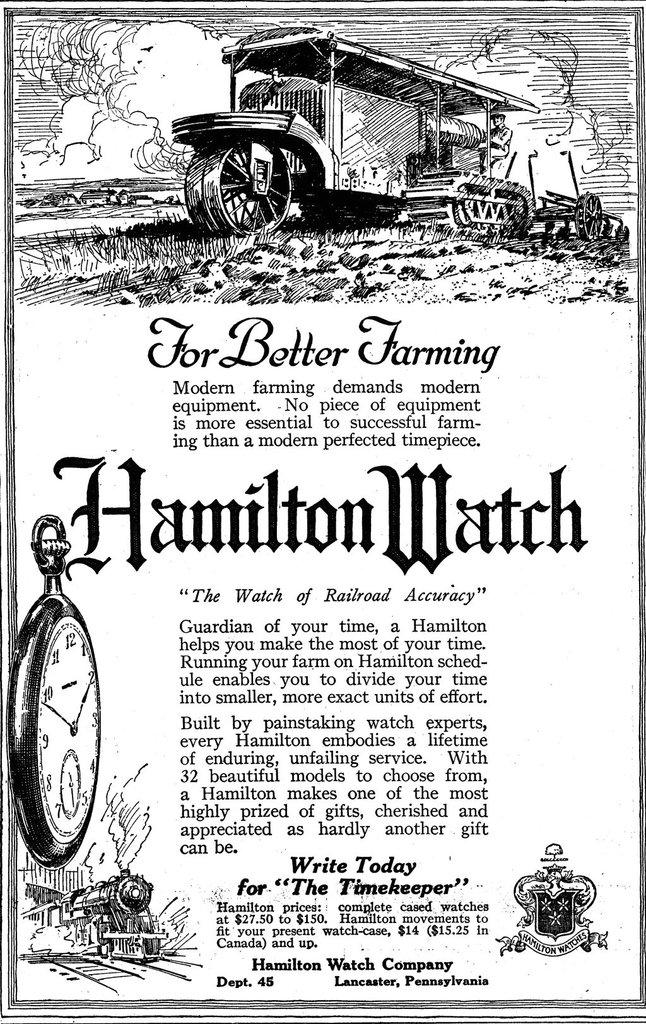<image>
Share a concise interpretation of the image provided. A black and white, old fashioned news article on better farming was published by the Hamilton Watch Company. 